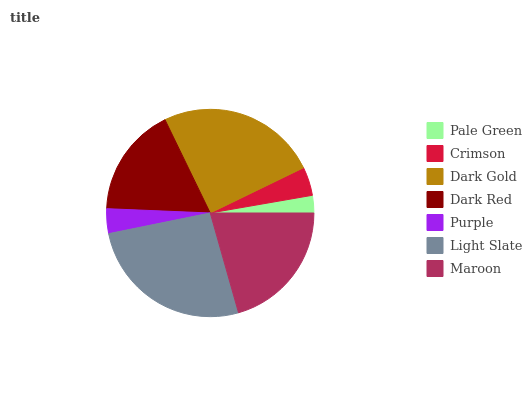Is Pale Green the minimum?
Answer yes or no. Yes. Is Light Slate the maximum?
Answer yes or no. Yes. Is Crimson the minimum?
Answer yes or no. No. Is Crimson the maximum?
Answer yes or no. No. Is Crimson greater than Pale Green?
Answer yes or no. Yes. Is Pale Green less than Crimson?
Answer yes or no. Yes. Is Pale Green greater than Crimson?
Answer yes or no. No. Is Crimson less than Pale Green?
Answer yes or no. No. Is Dark Red the high median?
Answer yes or no. Yes. Is Dark Red the low median?
Answer yes or no. Yes. Is Maroon the high median?
Answer yes or no. No. Is Maroon the low median?
Answer yes or no. No. 